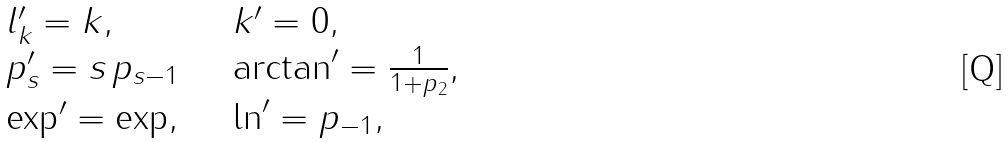<formula> <loc_0><loc_0><loc_500><loc_500>\begin{array} { l l } l ^ { \prime } _ { k } = k , & \quad k ^ { \prime } = 0 , \\ p ^ { \prime } _ { s } = s \, p _ { s - 1 } & \quad \arctan ^ { \prime } = \frac { 1 } { 1 + p _ { 2 } } , \\ \exp ^ { \prime } = \exp , & \quad \ln ^ { \prime } = p _ { - 1 } , \end{array}</formula> 